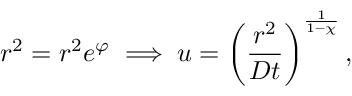<formula> <loc_0><loc_0><loc_500><loc_500>r ^ { 2 } = r ^ { 2 } e ^ { \varphi } \implies u = \left ( \frac { r ^ { 2 } } { D t } \right ) ^ { \frac { 1 } { 1 - \chi } } ,</formula> 